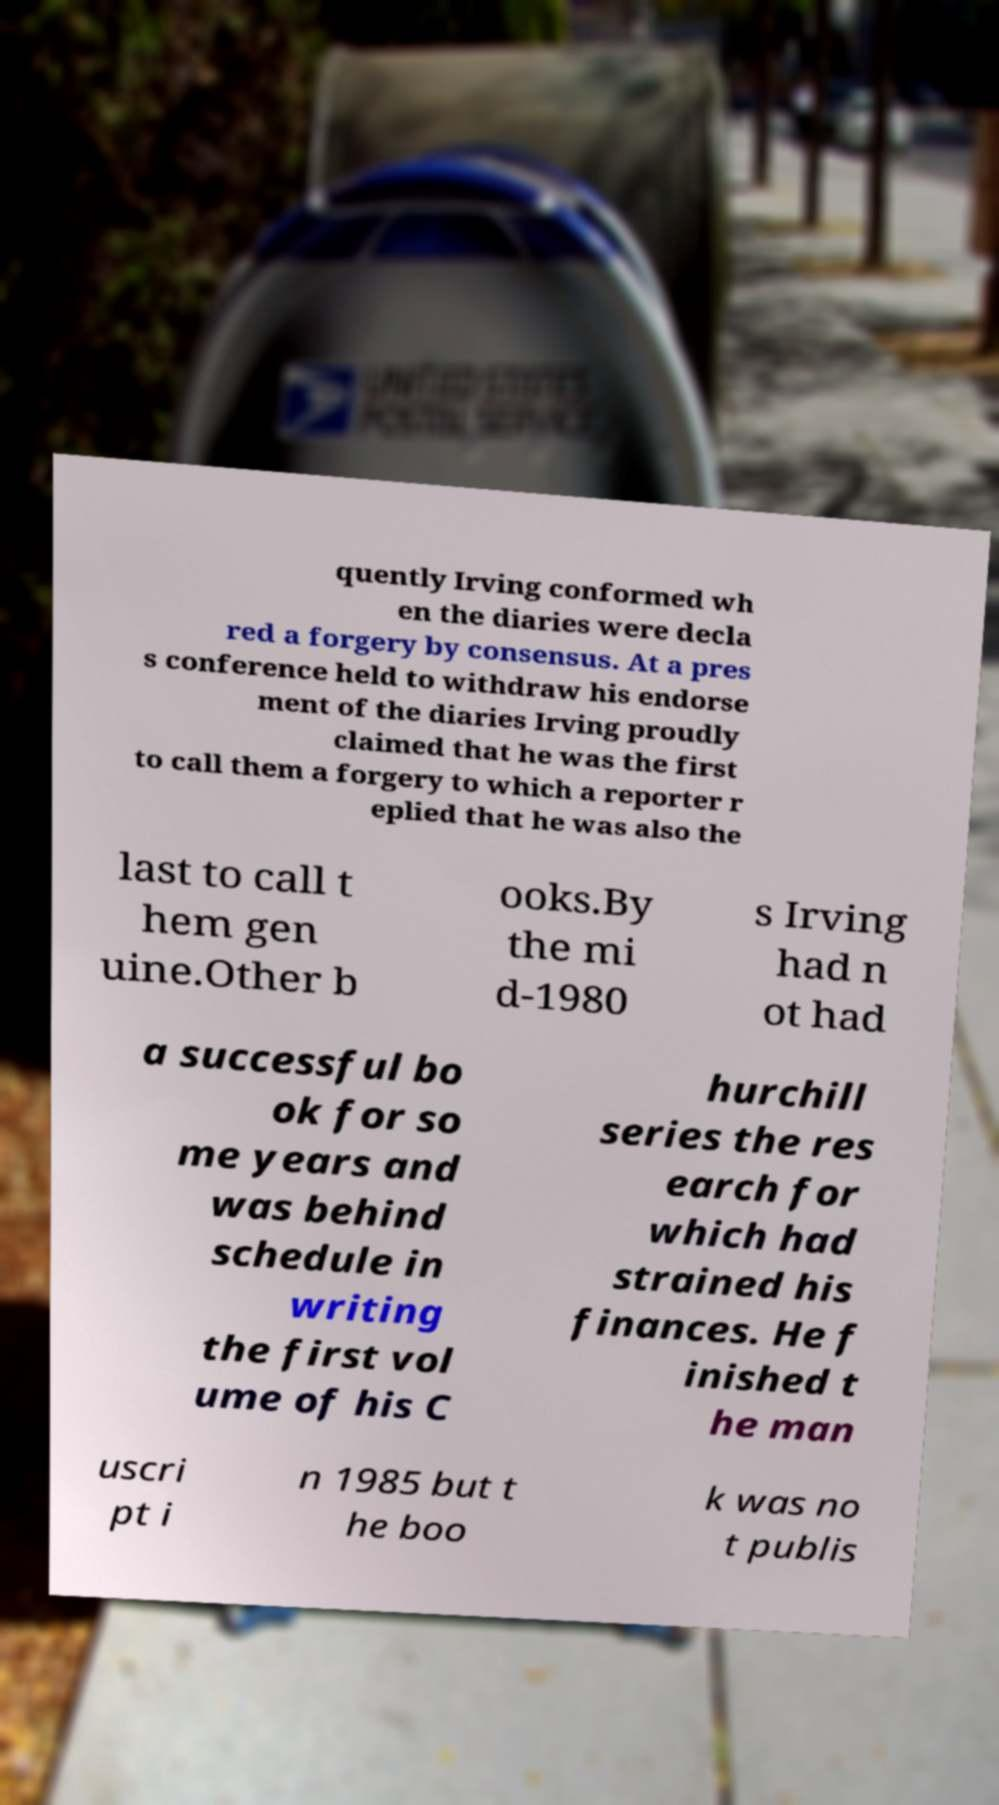Could you extract and type out the text from this image? quently Irving conformed wh en the diaries were decla red a forgery by consensus. At a pres s conference held to withdraw his endorse ment of the diaries Irving proudly claimed that he was the first to call them a forgery to which a reporter r eplied that he was also the last to call t hem gen uine.Other b ooks.By the mi d-1980 s Irving had n ot had a successful bo ok for so me years and was behind schedule in writing the first vol ume of his C hurchill series the res earch for which had strained his finances. He f inished t he man uscri pt i n 1985 but t he boo k was no t publis 